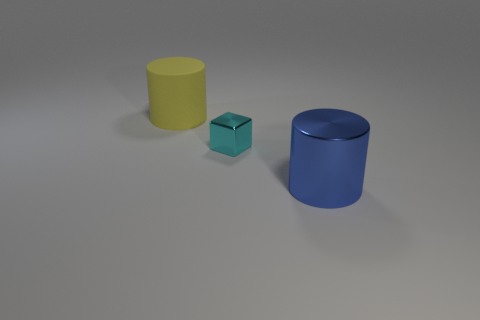Add 2 green objects. How many objects exist? 5 Subtract all cylinders. How many objects are left? 1 Subtract 0 cyan spheres. How many objects are left? 3 Subtract all blue shiny objects. Subtract all small green rubber balls. How many objects are left? 2 Add 1 blue cylinders. How many blue cylinders are left? 2 Add 2 tiny yellow shiny cylinders. How many tiny yellow shiny cylinders exist? 2 